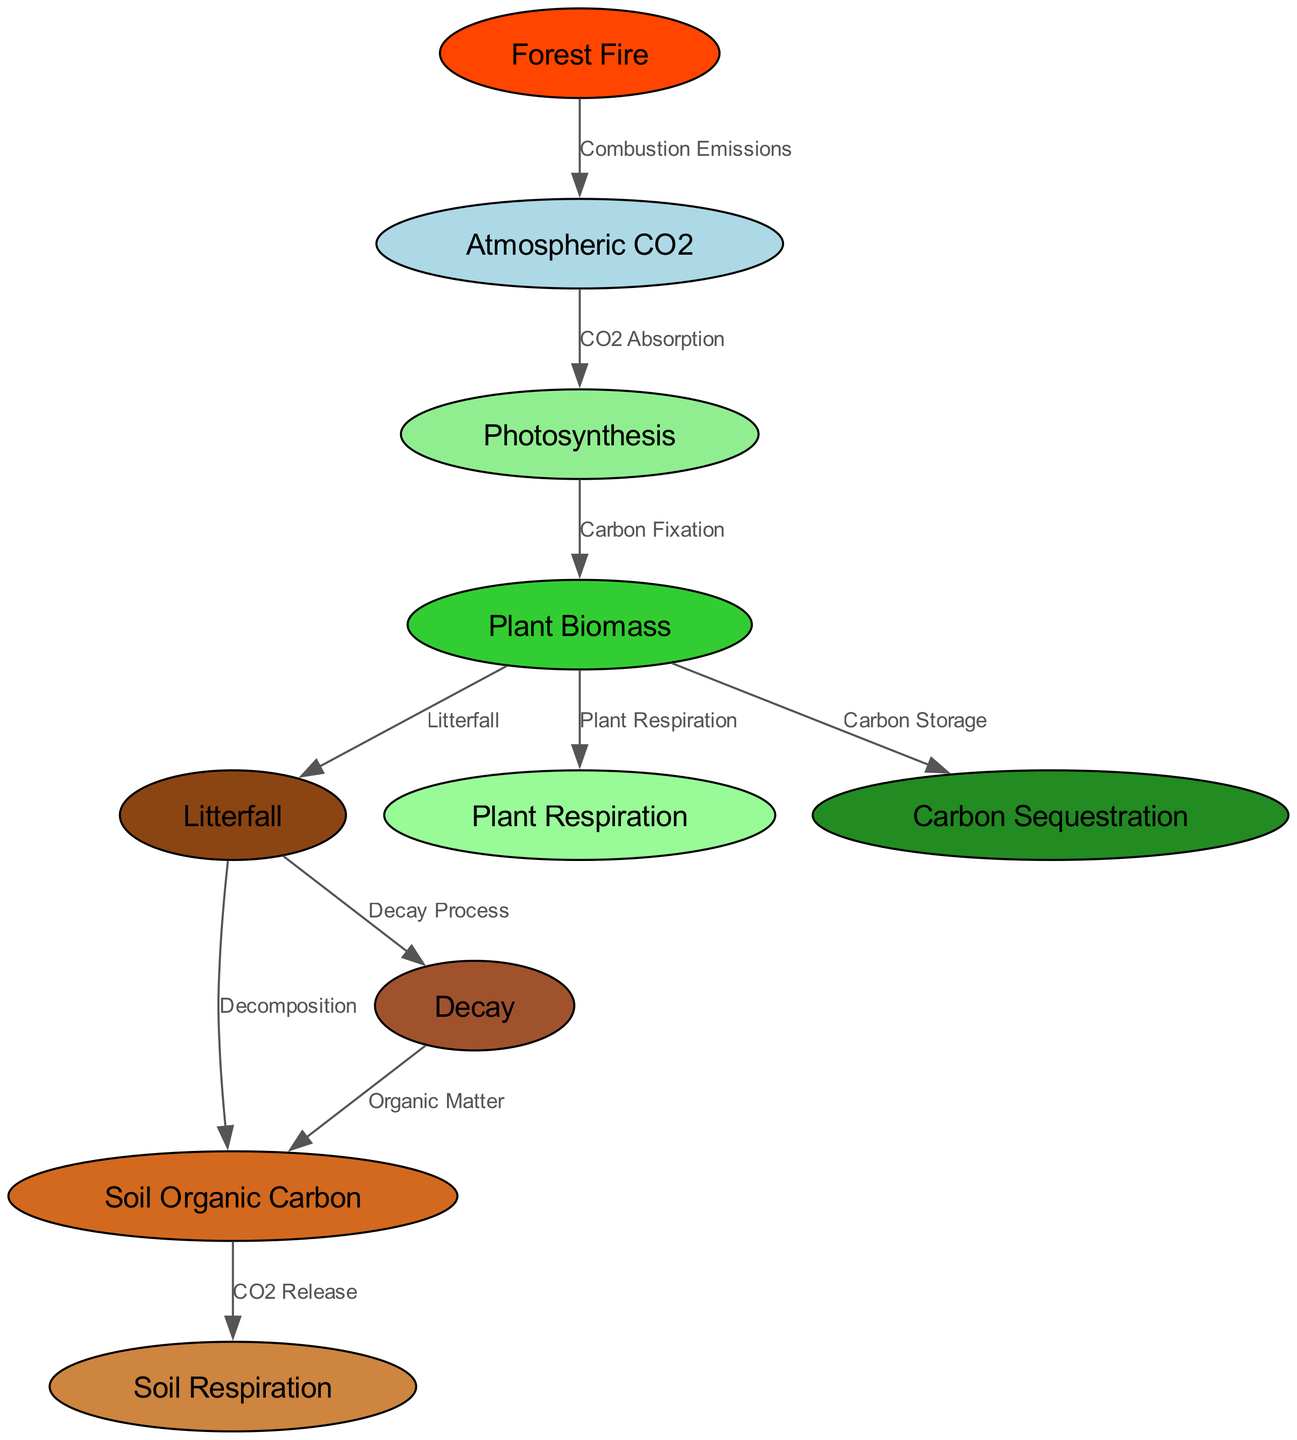What is the first step in the forest carbon cycle? The first step involves "CO2 Absorption" from the "Atmospheric CO2" node to the "Photosynthesis" node. This is indicated by the directed edge from atmospheric_CO2 to photosynthesis.
Answer: CO2 Absorption How many nodes are there in the diagram? By counting the entries in the "nodes" section of the data, there are a total of 10 nodes represented in the diagram.
Answer: 10 What type of emissions are associated with forest fires? The edge from the "Forest Fire" node connects to "Atmospheric CO2" with the label "Combustion Emissions," indicating that forest fires release carbon into the atmosphere.
Answer: Combustion Emissions What process leads to the formation of soil organic carbon from litterfall? The edge from "Litterfall" to "Soil Organic Carbon" is labeled "Decomposition," indicating that the decomposition process of litterfall contributes to forming soil organic carbon.
Answer: Decomposition How does plant biomass contribute to carbon storage? The edge indicates that "Plant Biomass" connects to "Carbon Sequestration" with the label "Carbon Storage," showing that plant biomass plays a direct role in carbon storage through sequestration.
Answer: Carbon Storage What is the relationship between soil respiration and soil organic carbon? The "Soil Organic Carbon" node has an outgoing edge to "Soil Respiration" labeled "CO2 Release," showing that soil respiration is the process by which CO2 is released from soil organic carbon.
Answer: CO2 Release Which node is directly influenced by plant respiration? The edge connecting "Plant Biomass" to "Plant Respiration" indicates a direct influence, where plant biomass contributes to the process of plant respiration, resulting in CO2 being released.
Answer: Plant Respiration In which process is organic matter generated? The edge labeled "Decay Process" indicates that the "Litterfall" node leads to the "Decay" node, which is where organic matter is generated through the decay of litterfall.
Answer: Decay Process What is the total number of edges present in the diagram? By counting the entries in the "edges" section of the data, there are a total of 10 edges that describe the relationships between the nodes in the diagram.
Answer: 10 